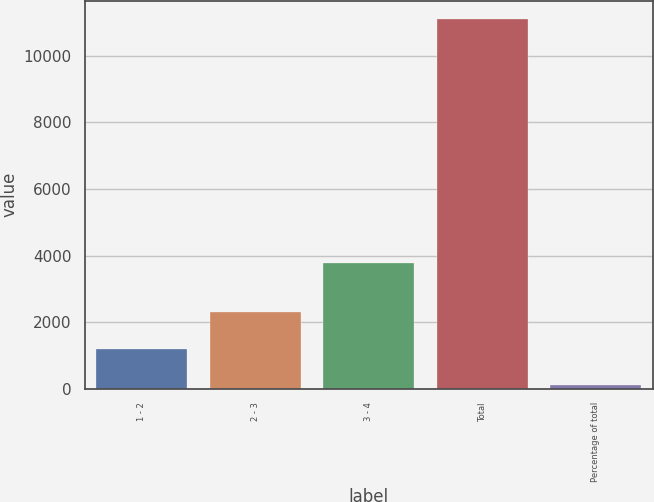Convert chart to OTSL. <chart><loc_0><loc_0><loc_500><loc_500><bar_chart><fcel>1 - 2<fcel>2 - 3<fcel>3 - 4<fcel>Total<fcel>Percentage of total<nl><fcel>1200.1<fcel>2304<fcel>3792<fcel>11101<fcel>100<nl></chart> 